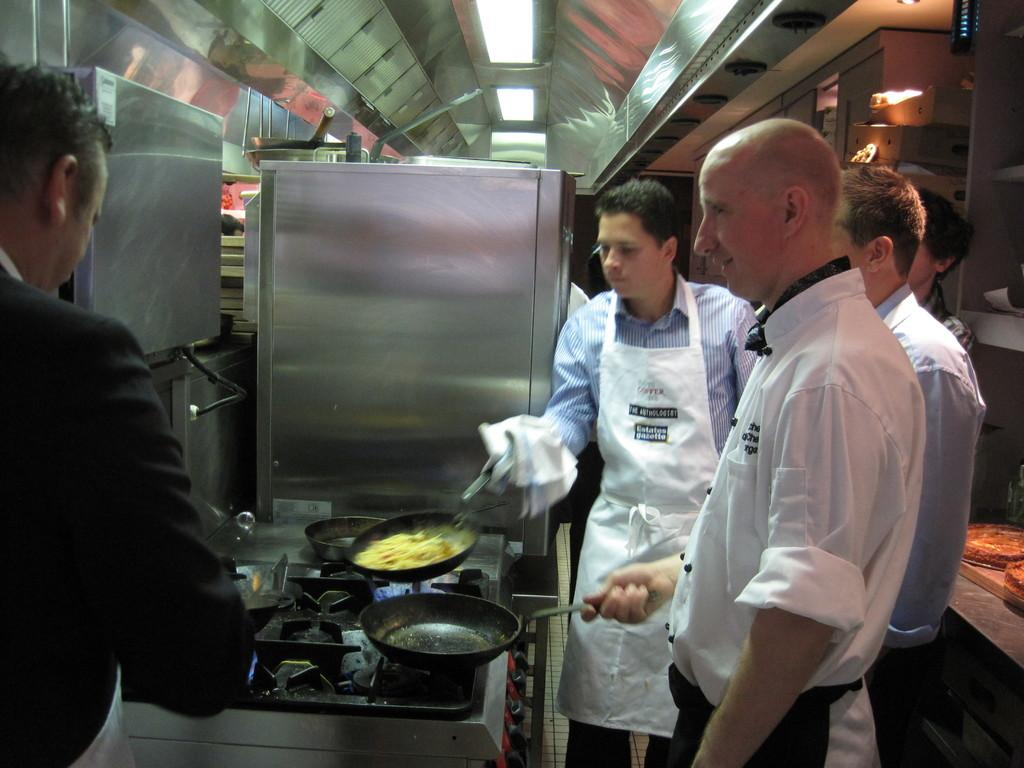What type of professionals are present in the image? There are chefs in the image. What are the chefs holding in their hands? The chefs are holding vessels in their hands. What can be seen in the middle of the image? There is a stove in the middle of the image. What is visible above the chefs and stove? There is a ceiling visible in the image. What type of cushion is being stitched by the chefs in the image? There is no cushion or stitching activity present in the image; the chefs are holding vessels and standing near a stove. How many thumbs does the chef on the left have in the image? The image does not provide enough detail to count the number of thumbs on the chef's hand. 